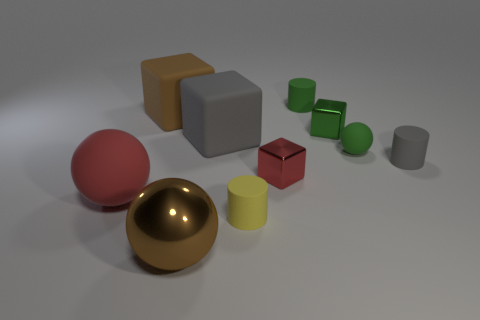Subtract all red blocks. How many blocks are left? 3 Subtract 1 cylinders. How many cylinders are left? 2 Subtract all green blocks. How many blocks are left? 3 Subtract all balls. How many objects are left? 7 Subtract 1 red balls. How many objects are left? 9 Subtract all gray cubes. Subtract all brown cylinders. How many cubes are left? 3 Subtract all tiny matte cylinders. Subtract all red balls. How many objects are left? 6 Add 7 yellow matte cylinders. How many yellow matte cylinders are left? 8 Add 4 blue metal blocks. How many blue metal blocks exist? 4 